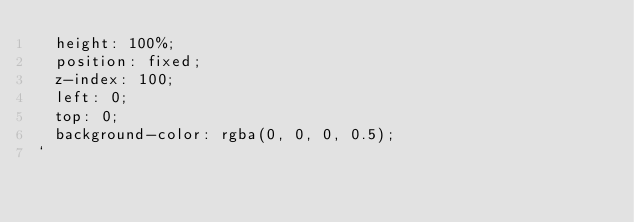<code> <loc_0><loc_0><loc_500><loc_500><_JavaScript_>  height: 100%;
  position: fixed;
  z-index: 100;
  left: 0;
  top: 0;
  background-color: rgba(0, 0, 0, 0.5);
`
</code> 